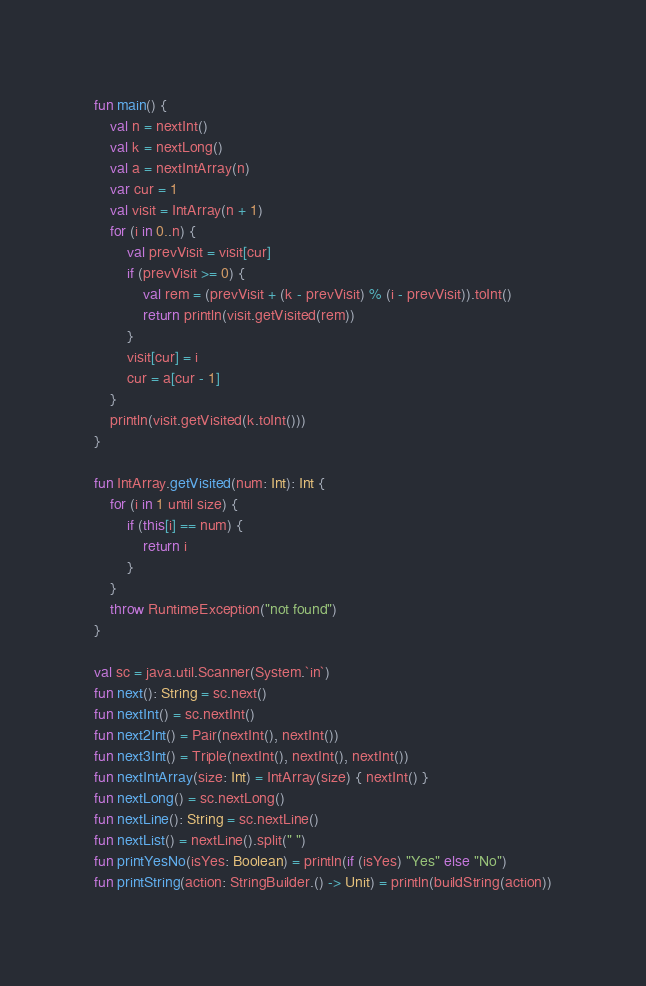Convert code to text. <code><loc_0><loc_0><loc_500><loc_500><_Kotlin_>fun main() {
    val n = nextInt()
    val k = nextLong()
    val a = nextIntArray(n)
    var cur = 1
    val visit = IntArray(n + 1)
    for (i in 0..n) {
        val prevVisit = visit[cur]
        if (prevVisit >= 0) {
            val rem = (prevVisit + (k - prevVisit) % (i - prevVisit)).toInt()
            return println(visit.getVisited(rem))
        }
        visit[cur] = i
        cur = a[cur - 1]
    }
    println(visit.getVisited(k.toInt()))
}

fun IntArray.getVisited(num: Int): Int {
    for (i in 1 until size) {
        if (this[i] == num) {
            return i
        }
    }
    throw RuntimeException("not found")
}

val sc = java.util.Scanner(System.`in`)
fun next(): String = sc.next()
fun nextInt() = sc.nextInt()
fun next2Int() = Pair(nextInt(), nextInt())
fun next3Int() = Triple(nextInt(), nextInt(), nextInt())
fun nextIntArray(size: Int) = IntArray(size) { nextInt() }
fun nextLong() = sc.nextLong()
fun nextLine(): String = sc.nextLine()
fun nextList() = nextLine().split(" ")
fun printYesNo(isYes: Boolean) = println(if (isYes) "Yes" else "No")
fun printString(action: StringBuilder.() -> Unit) = println(buildString(action))
</code> 